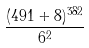<formula> <loc_0><loc_0><loc_500><loc_500>\frac { ( 4 9 1 + 8 ) ^ { 3 8 2 } } { 6 ^ { 2 } }</formula> 